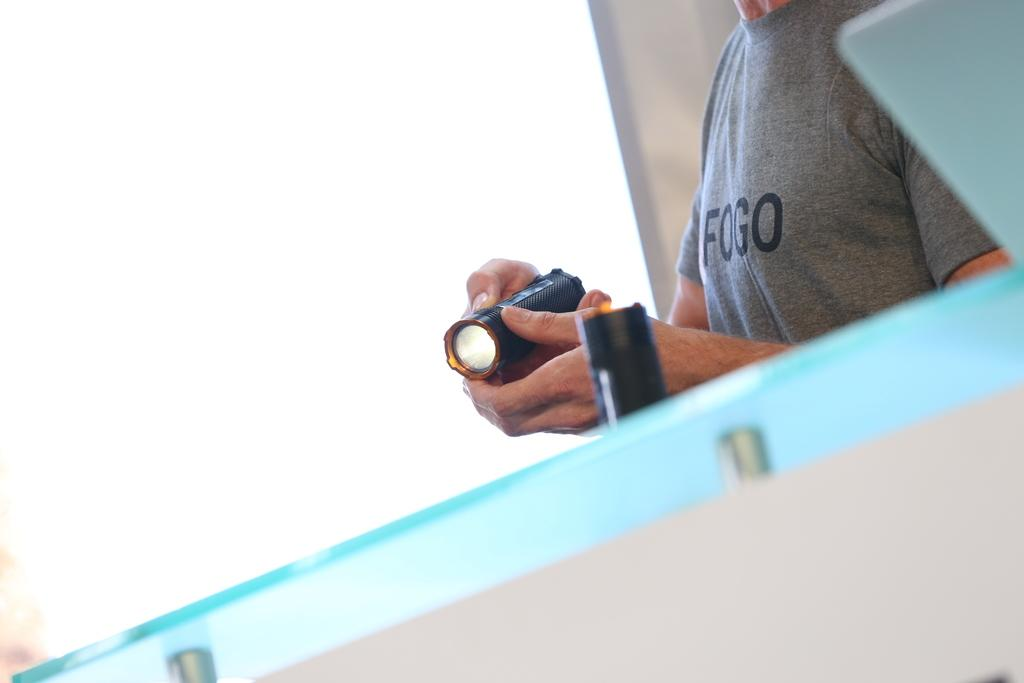What is the main object in the center of the image? There is a glass table in the center of the image. What is the person in the image doing? The person is standing and holding a torch light. What can be seen in the background of the image? There is a wall in the background of the image. Can you tell me how many goats are present in the image? There are no goats present in the image. What is the limit of the person's ability to help in the image? The image does not provide information about the person's ability to help or any limits on that ability. 